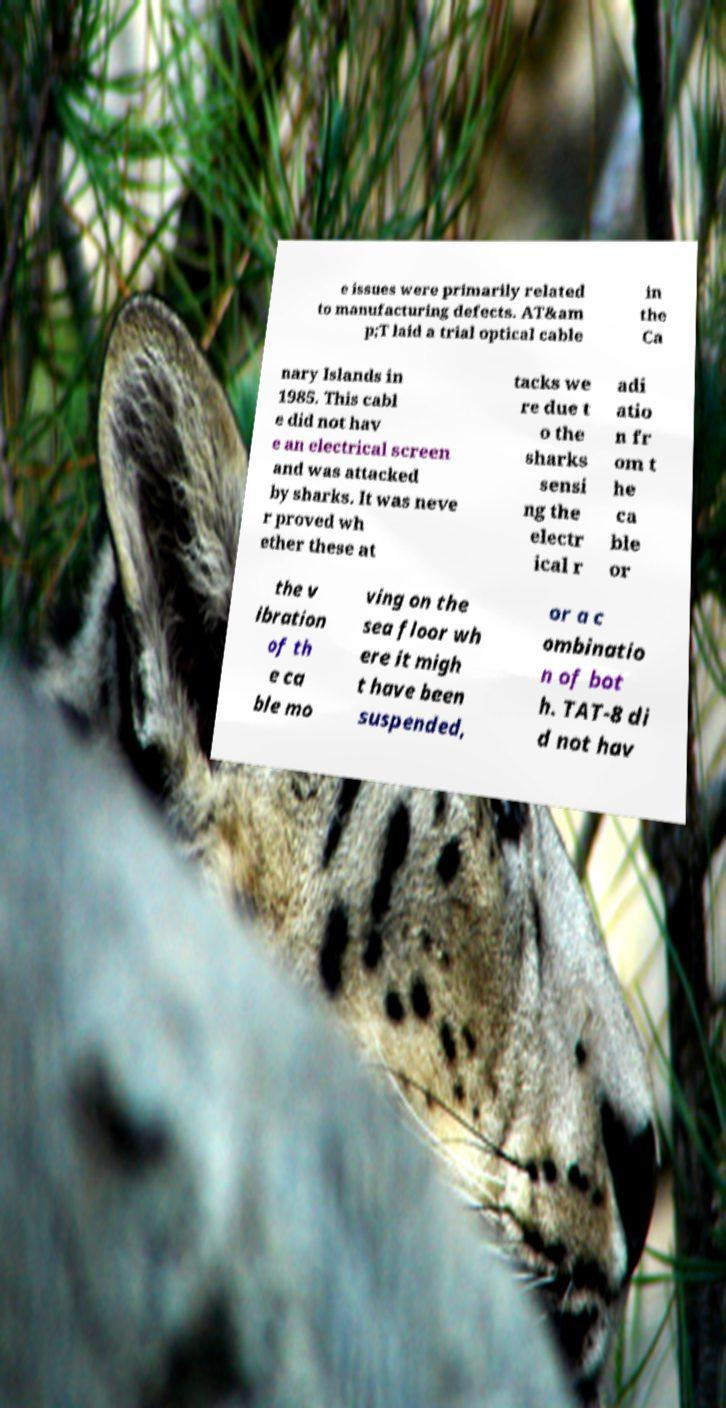For documentation purposes, I need the text within this image transcribed. Could you provide that? e issues were primarily related to manufacturing defects. AT&am p;T laid a trial optical cable in the Ca nary Islands in 1985. This cabl e did not hav e an electrical screen and was attacked by sharks. It was neve r proved wh ether these at tacks we re due t o the sharks sensi ng the electr ical r adi atio n fr om t he ca ble or the v ibration of th e ca ble mo ving on the sea floor wh ere it migh t have been suspended, or a c ombinatio n of bot h. TAT-8 di d not hav 